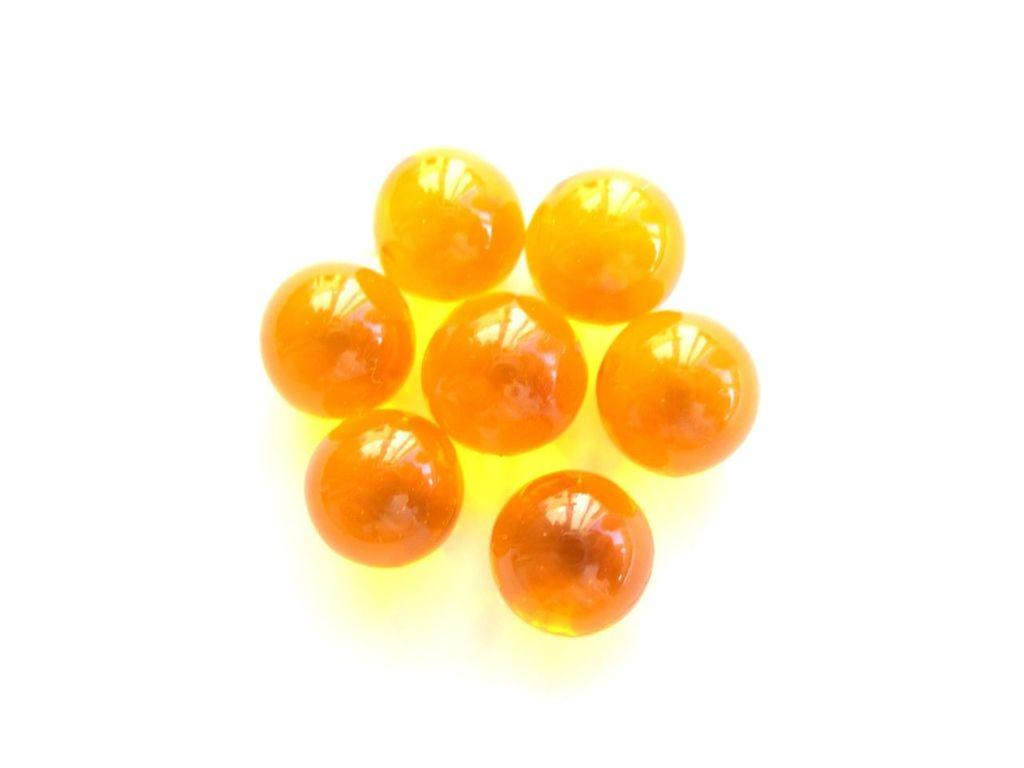What type of objects are present in the image? There are yellow circular objects in the image. What do these objects resemble? The objects resemble marbles. What color is the background of the image? The background of the image is white. How many pigs are present in the image? There are no pigs present in the image; it features yellow circular objects that resemble marbles against a white background. 